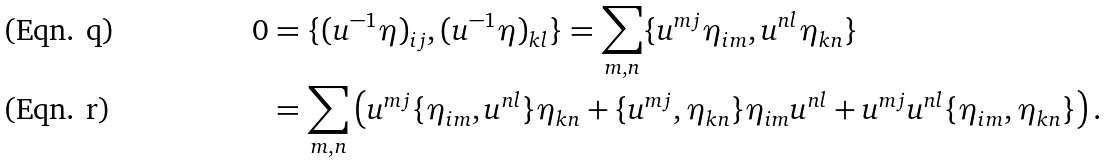Convert formula to latex. <formula><loc_0><loc_0><loc_500><loc_500>0 & = \{ ( u ^ { - 1 } \eta ) _ { i j } , ( u ^ { - 1 } \eta ) _ { k l } \} = \sum _ { m , n } \{ u ^ { m j } \eta _ { i m } , u ^ { n l } \eta _ { k n } \} \\ & = \sum _ { m , n } \left ( u ^ { m j } \{ \eta _ { i m } , u ^ { n l } \} \eta _ { k n } + \{ u ^ { m j } , \eta _ { k n } \} \eta _ { i m } u ^ { n l } + u ^ { m j } u ^ { n l } \{ \eta _ { i m } , \eta _ { k n } \} \right ) .</formula> 